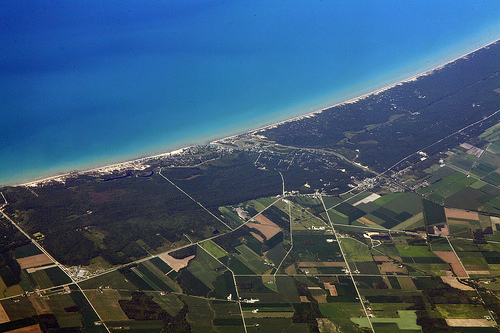<image>
Is the water on the field? No. The water is not positioned on the field. They may be near each other, but the water is not supported by or resting on top of the field. 